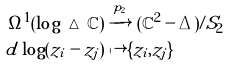Convert formula to latex. <formula><loc_0><loc_0><loc_500><loc_500>\Omega ^ { 1 } ( \log \, \vartriangle \, \mathbb { C } ) & \xrightarrow { p _ { 2 } } ( \mathbb { C } ^ { 2 } - \Delta ) / S _ { 2 } \\ d \log ( z _ { i } - z _ { j } ) & \mapsto \{ z _ { i } , z _ { j } \}</formula> 